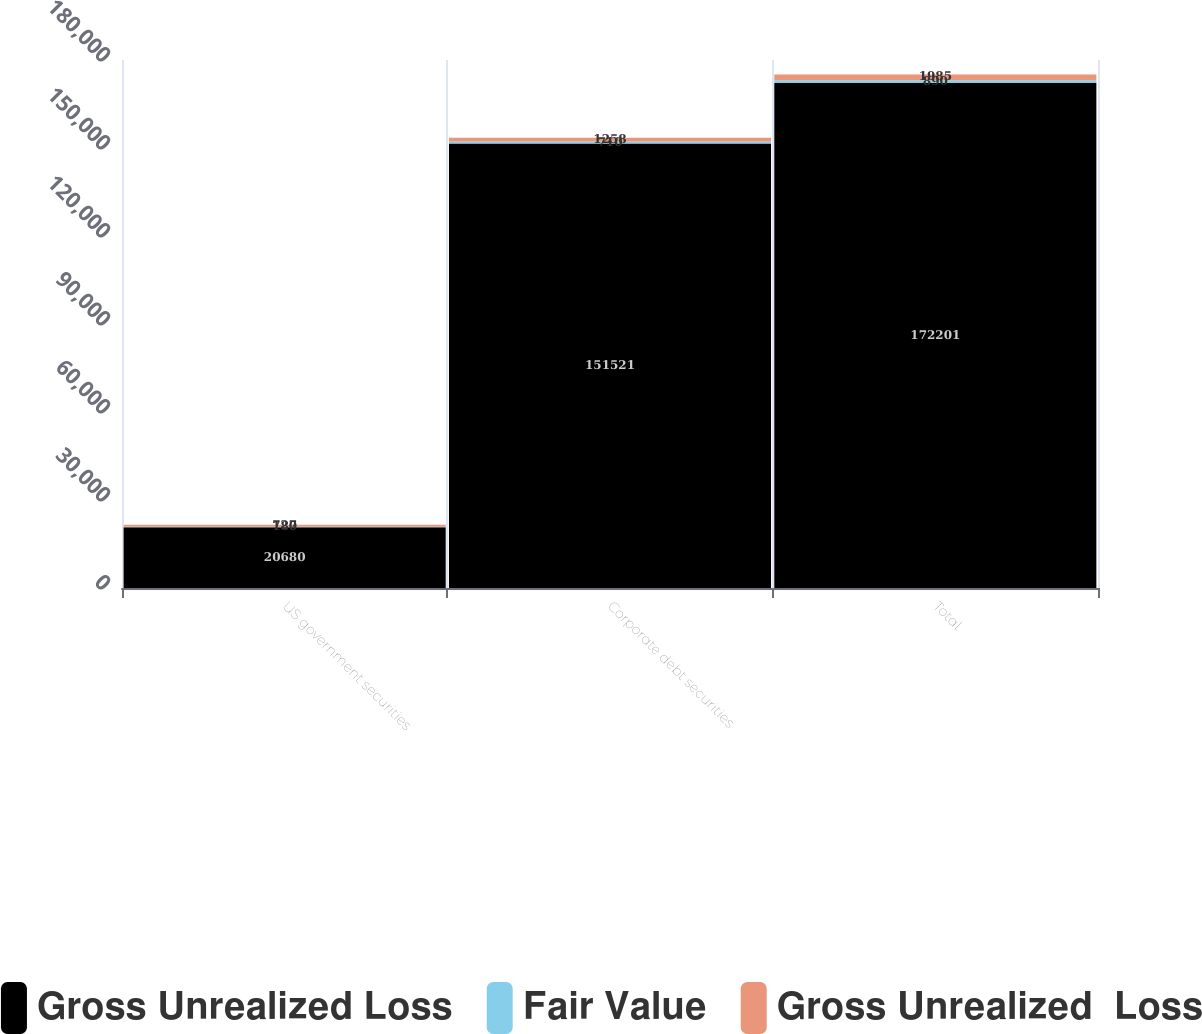Convert chart. <chart><loc_0><loc_0><loc_500><loc_500><stacked_bar_chart><ecel><fcel>US government securities<fcel>Corporate debt securities<fcel>Total<nl><fcel>Gross Unrealized Loss<fcel>20680<fcel>151521<fcel>172201<nl><fcel>Fair Value<fcel>180<fcel>710<fcel>890<nl><fcel>Gross Unrealized  Loss<fcel>727<fcel>1258<fcel>1985<nl></chart> 